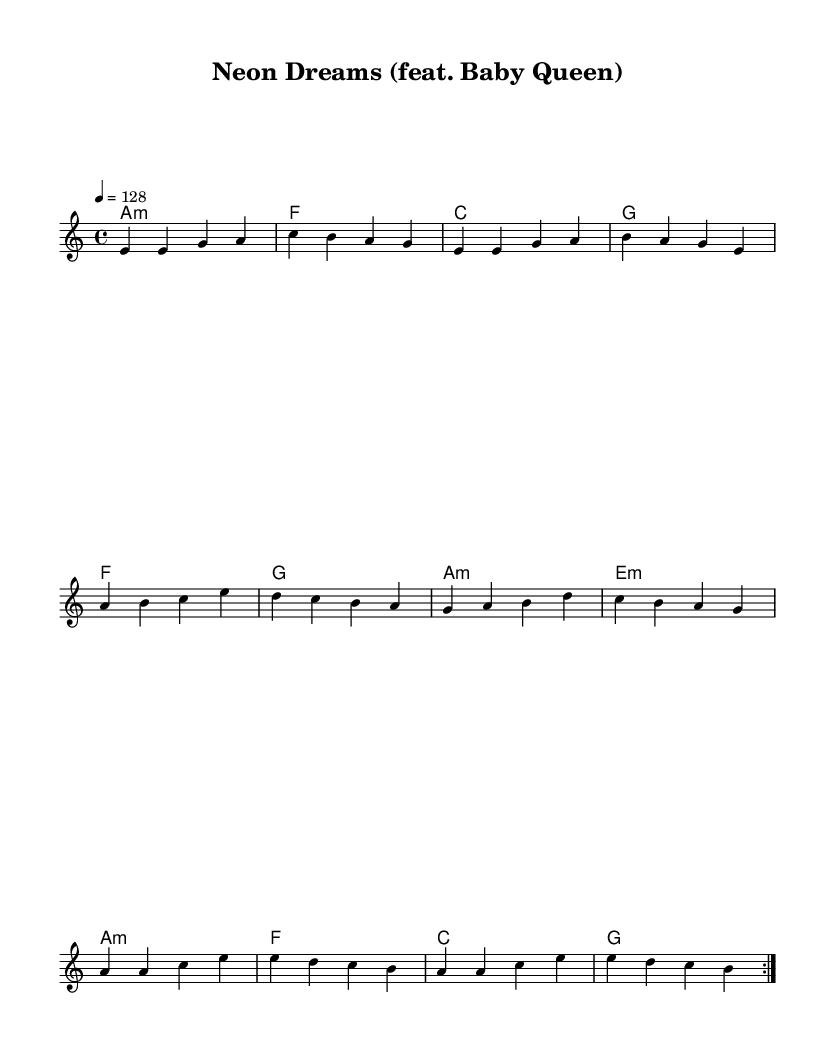What is the key signature of this music? The key signature is A minor, which contains no sharps or flats. This can be determined from the key indicated at the beginning of the score.
Answer: A minor What is the time signature of this piece? The time signature is 4/4, indicating that there are four beats in each measure and a quarter note gets one beat. This is visible in the beginning section of the sheet music.
Answer: 4/4 What is the tempo marking for this score? The tempo marking is 128 beats per minute, indicated above the staff. This tells us how fast the music should be played.
Answer: 128 How many measures are repeated in the melody? The melody has a repeat indicated by the "volta" sign, showing two measures of the melody must be played twice. This is indicated by the repeated markings in the score.
Answer: 2 What type of chords are predominantly used in this piece? The chords used include minor (a minor) and major chords (e and g). The chord mode notation indicates a mix of these types throughout the harmony section.
Answer: Minor and major What genre does this collaboration represent? The piece represents K-pop, infused with alternative pop elements, which is common in collaborations with Western indie artists. This conclusion is drawn from the collaboration context and the style reflected in the music's structure.
Answer: K-pop 